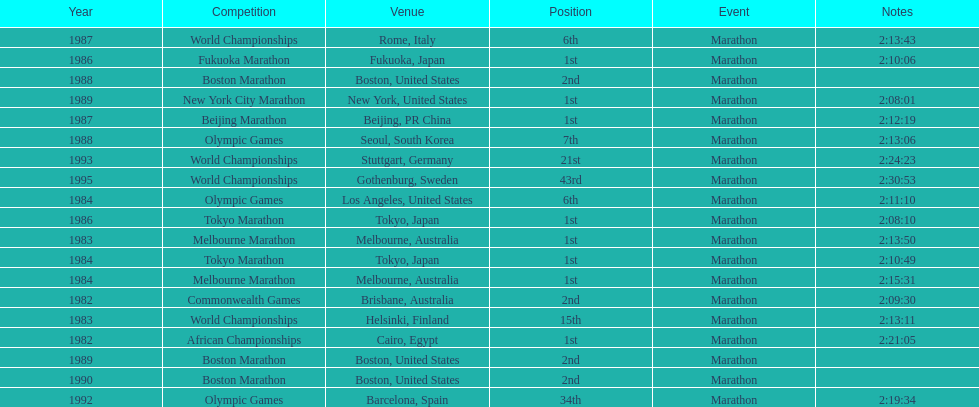What were the number of times the venue was located in the united states? 5. 